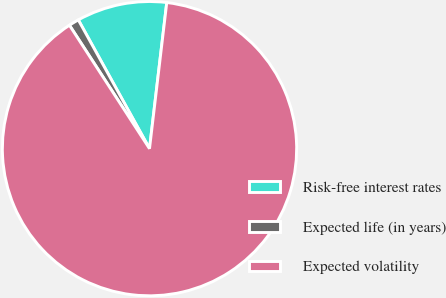<chart> <loc_0><loc_0><loc_500><loc_500><pie_chart><fcel>Risk-free interest rates<fcel>Expected life (in years)<fcel>Expected volatility<nl><fcel>9.91%<fcel>1.12%<fcel>88.97%<nl></chart> 